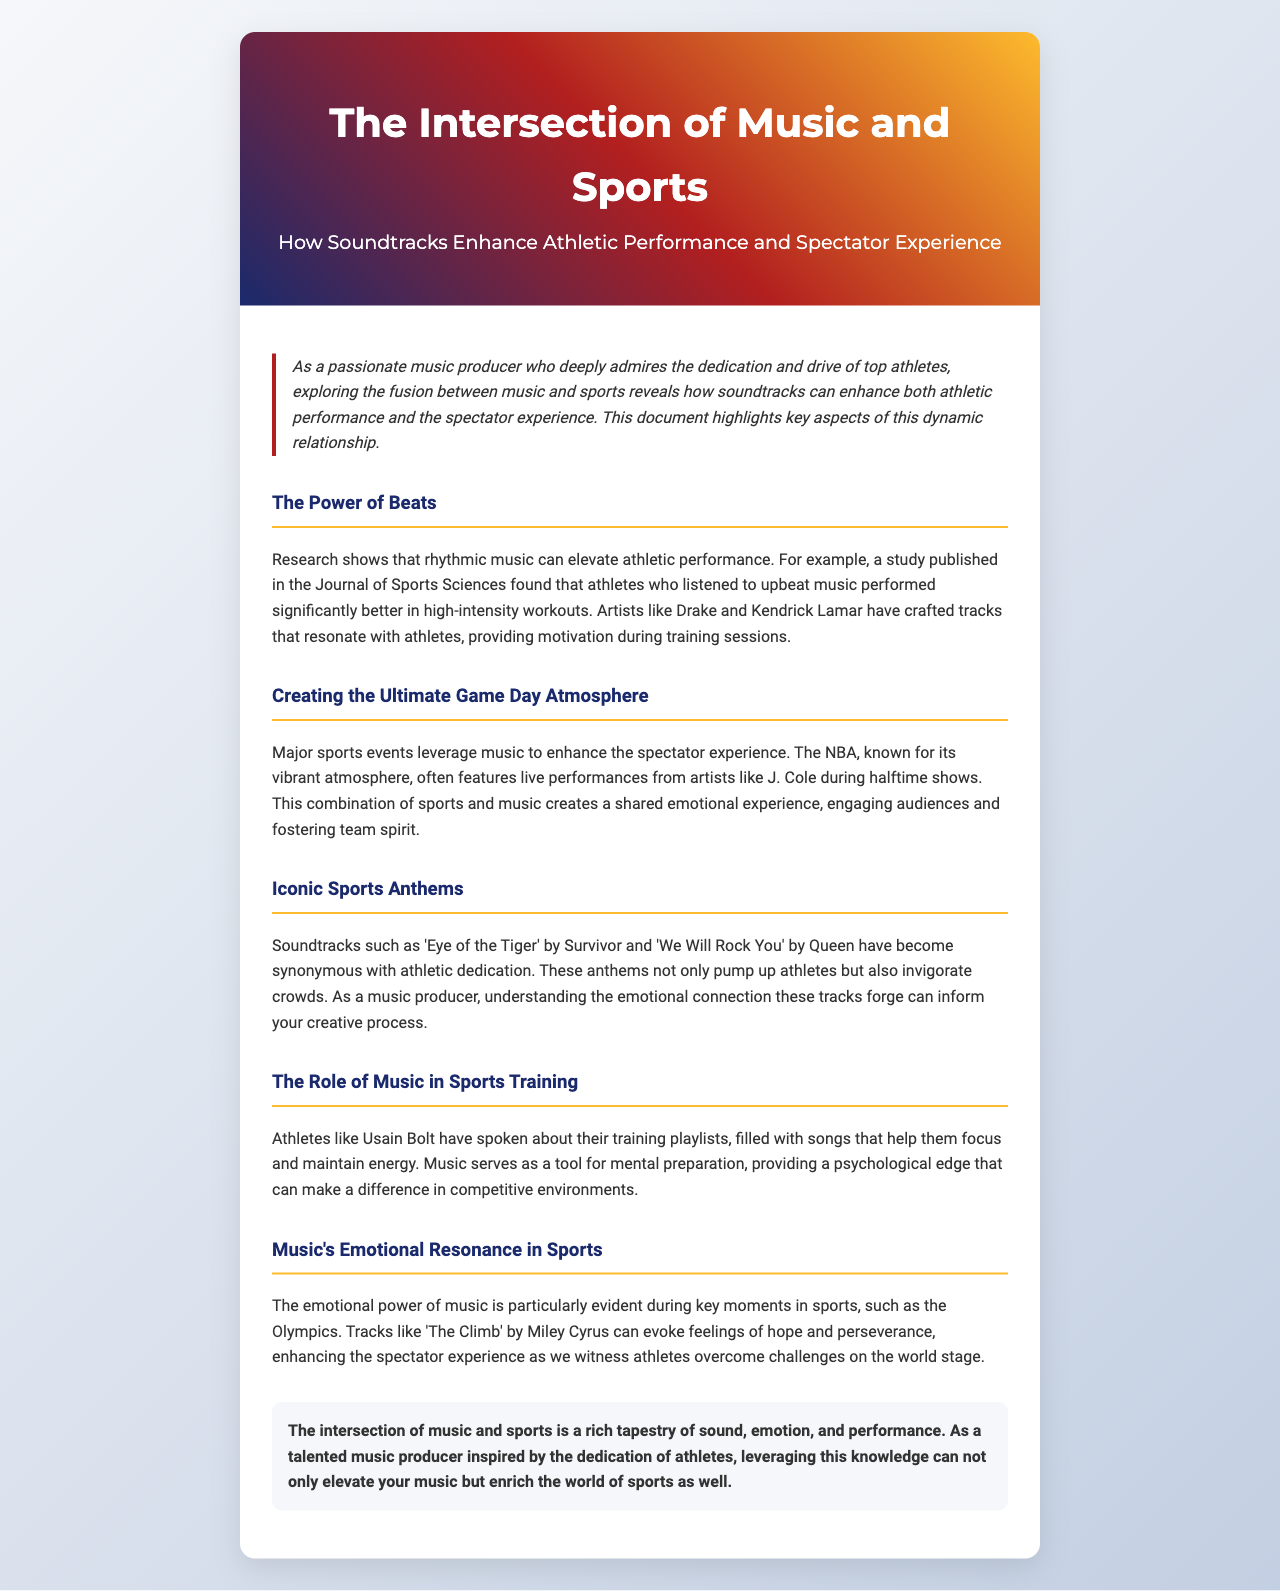What is the primary theme of the newsletter? The newsletter discusses the fusion between music and sports, highlighting how soundtracks enhance athletic performance and the spectator experience.
Answer: Intersection of Music and Sports Which artist is mentioned as performing during NBA halftime shows? J. Cole is highlighted as an artist who features in NBA halftime shows, contributing to the game day atmosphere.
Answer: J. Cole What iconic sports anthem is associated with Survivor? The song 'Eye of the Tiger' by Survivor is noted as an iconic sports anthem.
Answer: Eye of the Tiger Who is cited in the document as a notable athlete using music for training? Usain Bolt is mentioned regarding his use of music while training to maintain focus and energy.
Answer: Usain Bolt Which emotional song is referenced in relation to the Olympics? 'The Climb' by Miley Cyrus is discussed for its emotional resonance during key moments in sports like the Olympics.
Answer: The Climb What psychological advantage does music provide athletes? Music acts as a tool for mental preparation, giving athletes a psychological edge in competitive environments.
Answer: Psychological edge How do soundtracks affect spectator experiences? Soundtracks create a shared emotional experience, engaging audiences and fostering team spirit at events.
Answer: Shared emotional experience What is one benefit of rhythmic music in athletic performance? Rhythmic music can elevate athletic performance, as evidenced by research in the Journal of Sports Sciences.
Answer: Elevate athletic performance What type of music is often played during high-intensity workouts? Upbeat music is identified as beneficial for improving performance during high-intensity workouts.
Answer: Upbeat music 